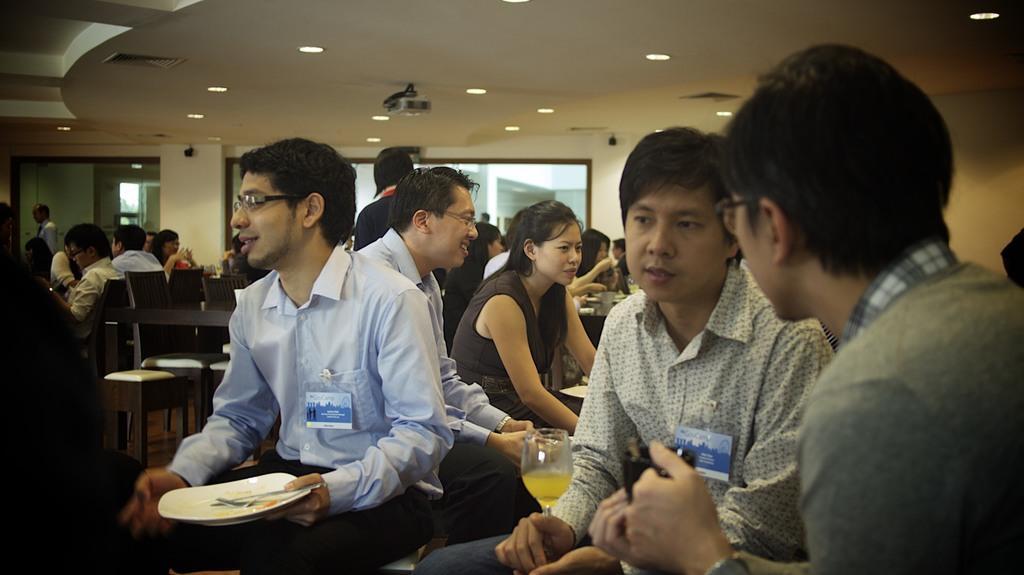Describe this image in one or two sentences. In the picture we can see a group of people sitting on the chairs near the tables and having a food and in the background, we can see a wall with glass windows and to the ceiling we can see the lights. 